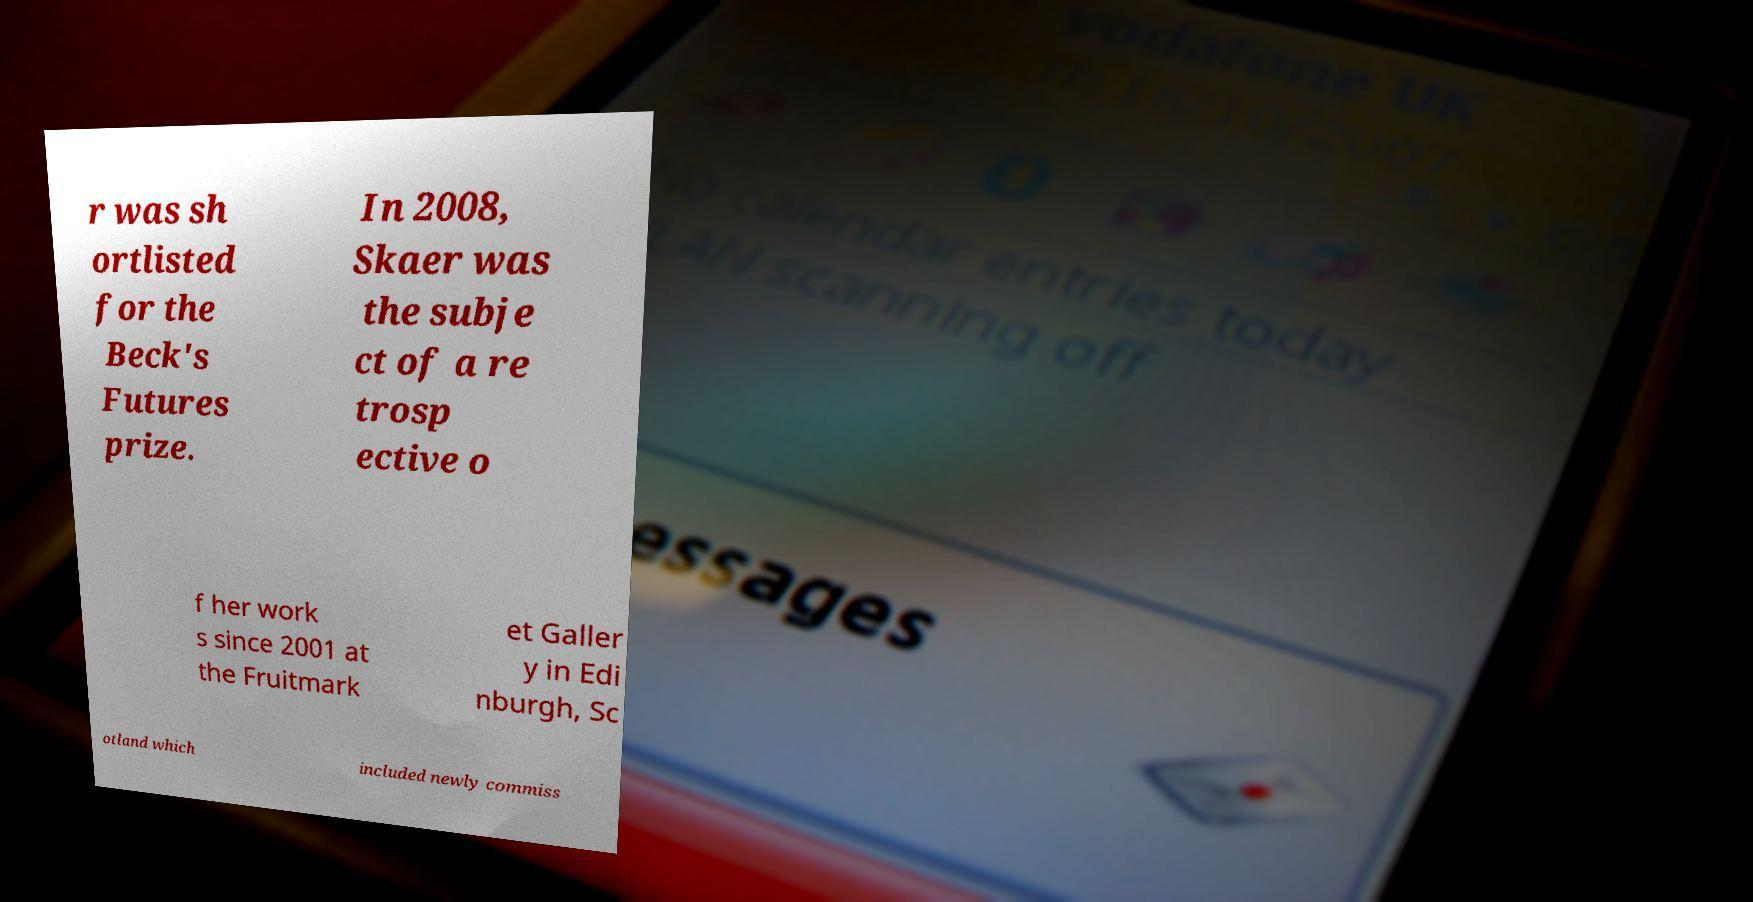Please identify and transcribe the text found in this image. r was sh ortlisted for the Beck's Futures prize. In 2008, Skaer was the subje ct of a re trosp ective o f her work s since 2001 at the Fruitmark et Galler y in Edi nburgh, Sc otland which included newly commiss 